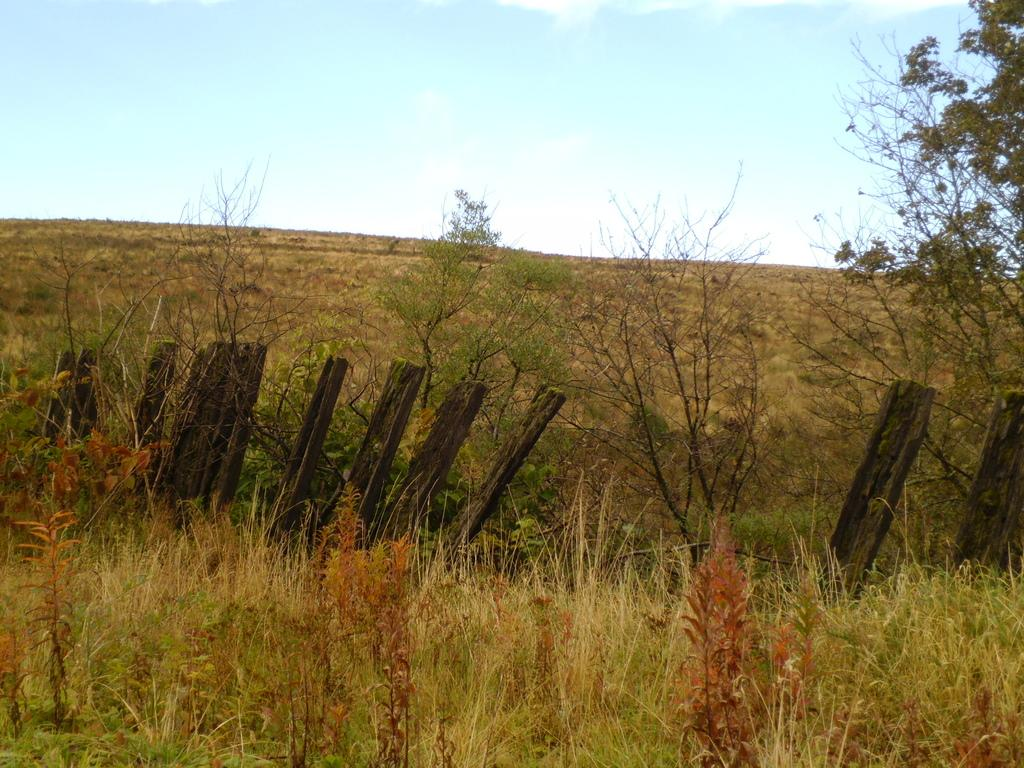What type of vegetation is present in the foreground of the image? There is green grass in the foreground of the image. What other natural elements can be seen in the image? There are trees in the image. What type of barrier is present in the image? There is fencing in the image. What can be seen in the sky in the image? Clouds are visible in the sky in the image. Can you describe the kiss between the sun and the clouds in the image? There is no kiss between the sun and the clouds in the image, as the sun is not visible. 